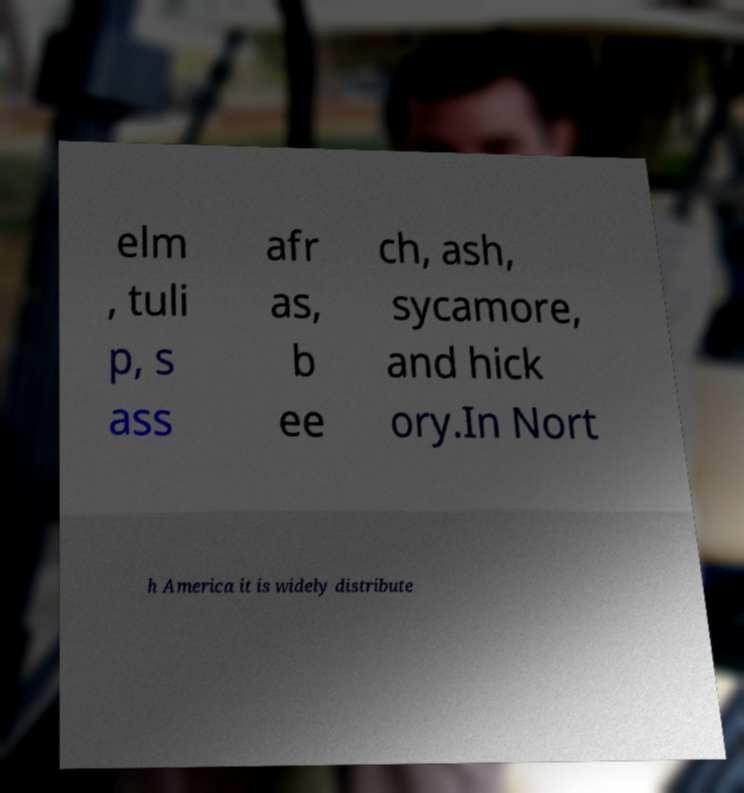Can you read and provide the text displayed in the image?This photo seems to have some interesting text. Can you extract and type it out for me? elm , tuli p, s ass afr as, b ee ch, ash, sycamore, and hick ory.In Nort h America it is widely distribute 